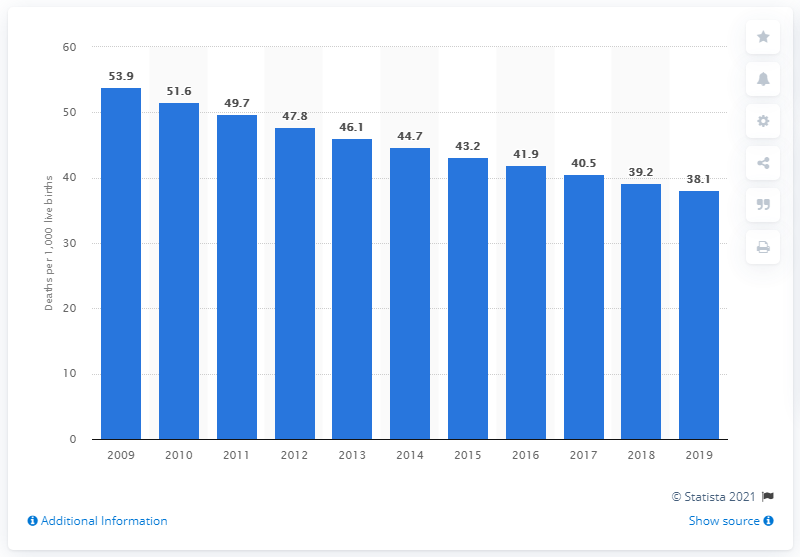Mention a couple of crucial points in this snapshot. In 2019, the infant mortality rate in Timor-Leste was 38.1 deaths per 1,000 live births. 